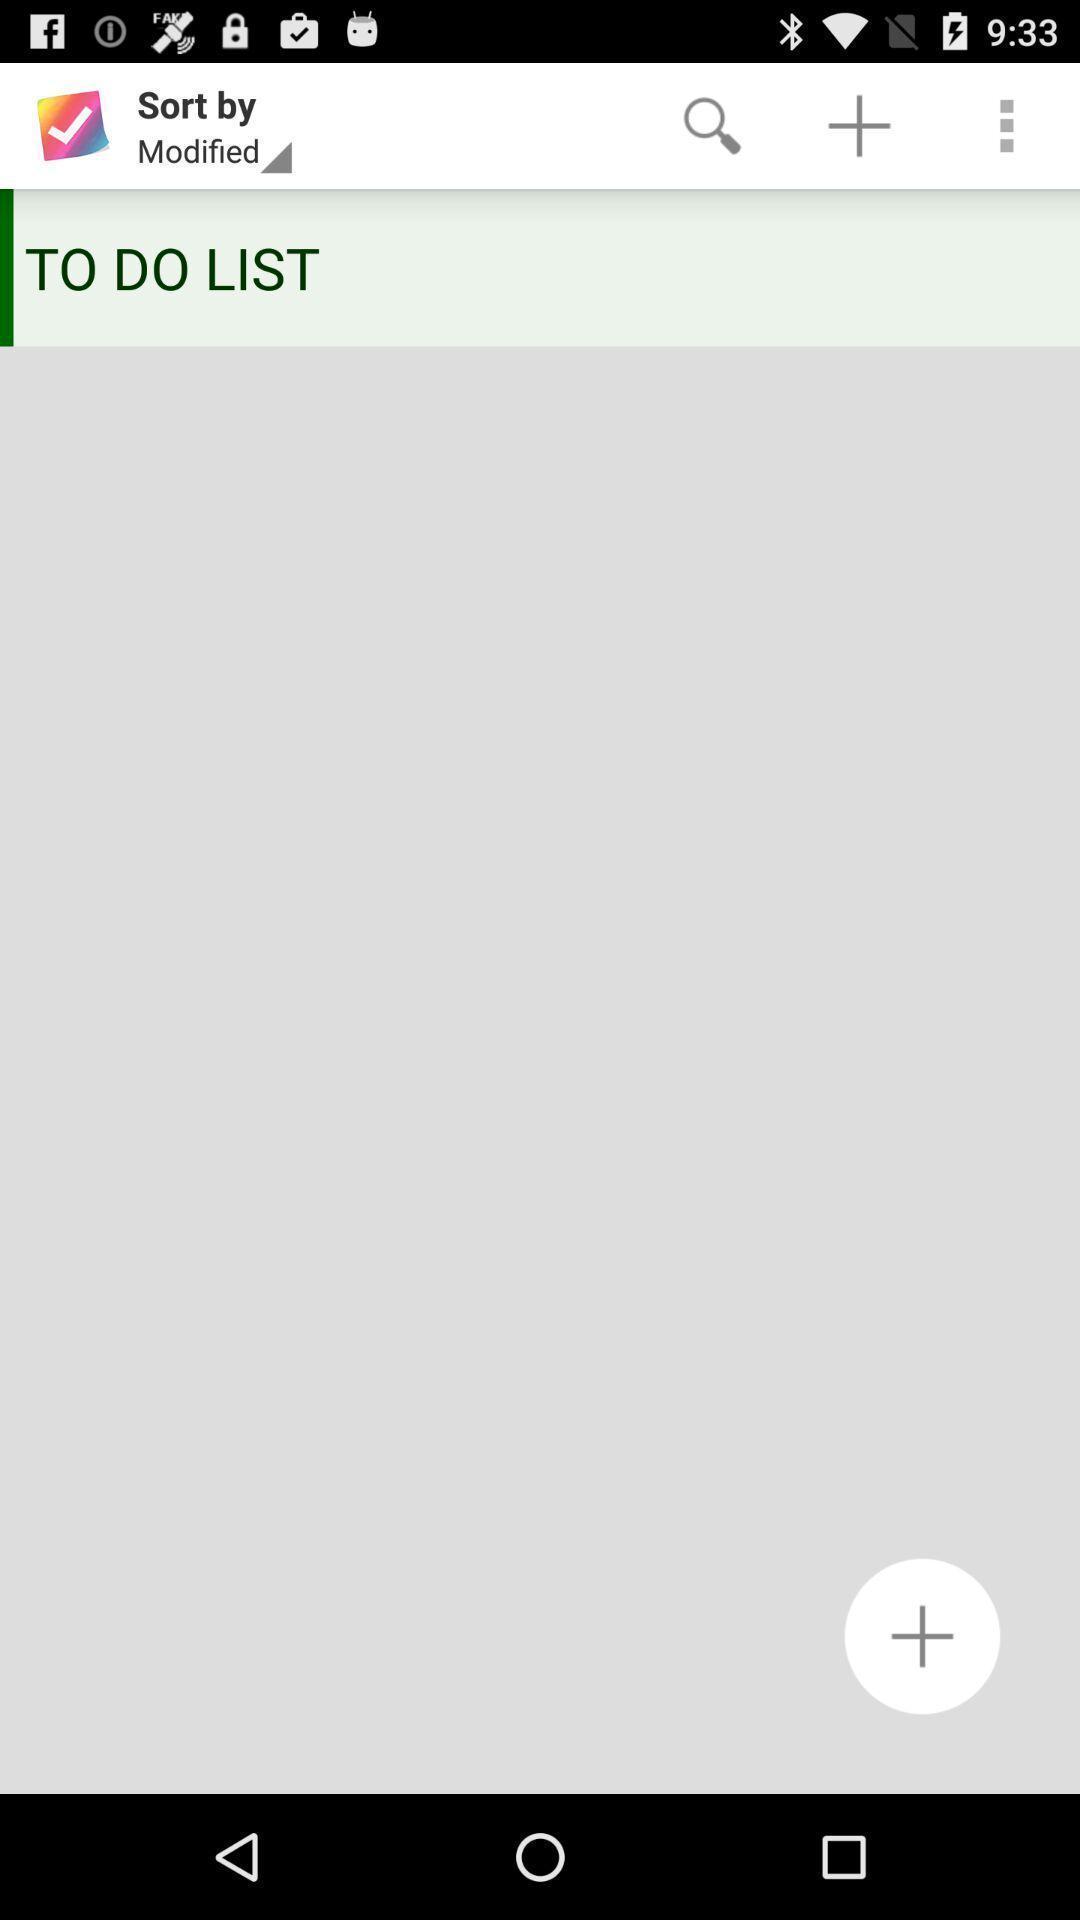Give me a narrative description of this picture. To do list in a display customization app. 